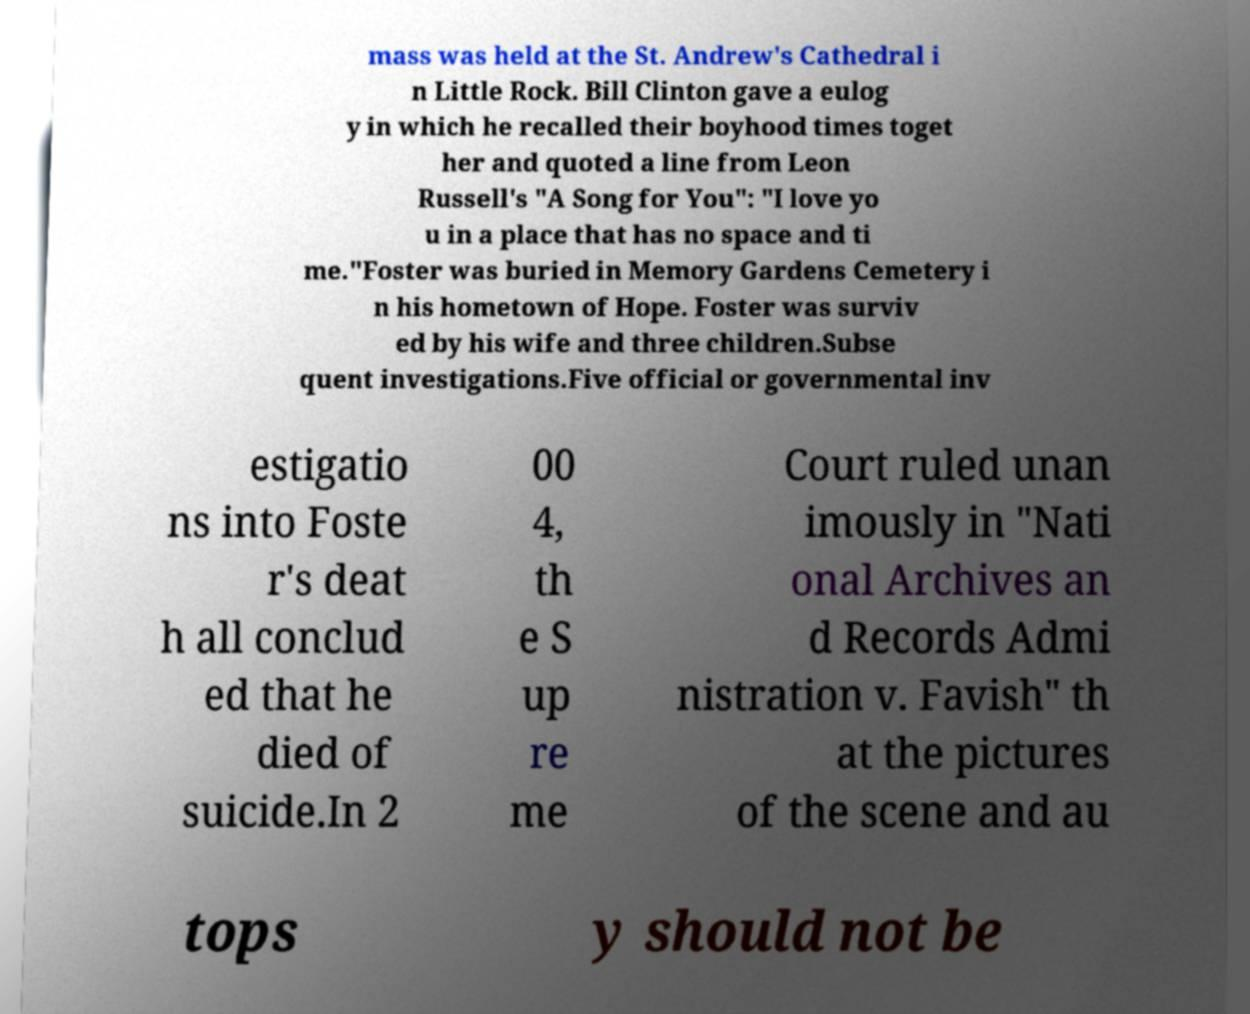Please identify and transcribe the text found in this image. mass was held at the St. Andrew's Cathedral i n Little Rock. Bill Clinton gave a eulog y in which he recalled their boyhood times toget her and quoted a line from Leon Russell's "A Song for You": "I love yo u in a place that has no space and ti me."Foster was buried in Memory Gardens Cemetery i n his hometown of Hope. Foster was surviv ed by his wife and three children.Subse quent investigations.Five official or governmental inv estigatio ns into Foste r's deat h all conclud ed that he died of suicide.In 2 00 4, th e S up re me Court ruled unan imously in "Nati onal Archives an d Records Admi nistration v. Favish" th at the pictures of the scene and au tops y should not be 